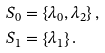Convert formula to latex. <formula><loc_0><loc_0><loc_500><loc_500>S _ { 0 } & = \left \{ \lambda _ { 0 } , \lambda _ { 2 } \right \} , \\ S _ { 1 } & = \left \{ \lambda _ { 1 } \right \} .</formula> 